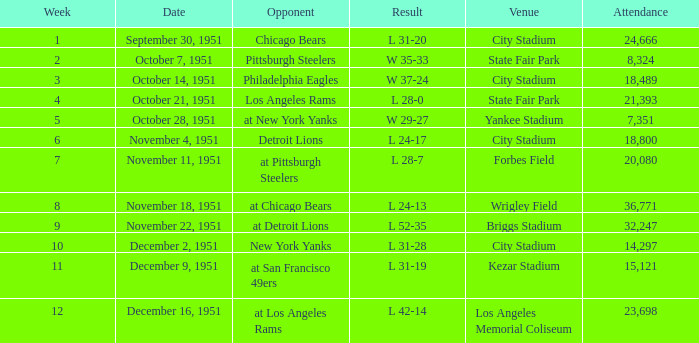Which place accommodated the los angeles rams as a rival? State Fair Park. 